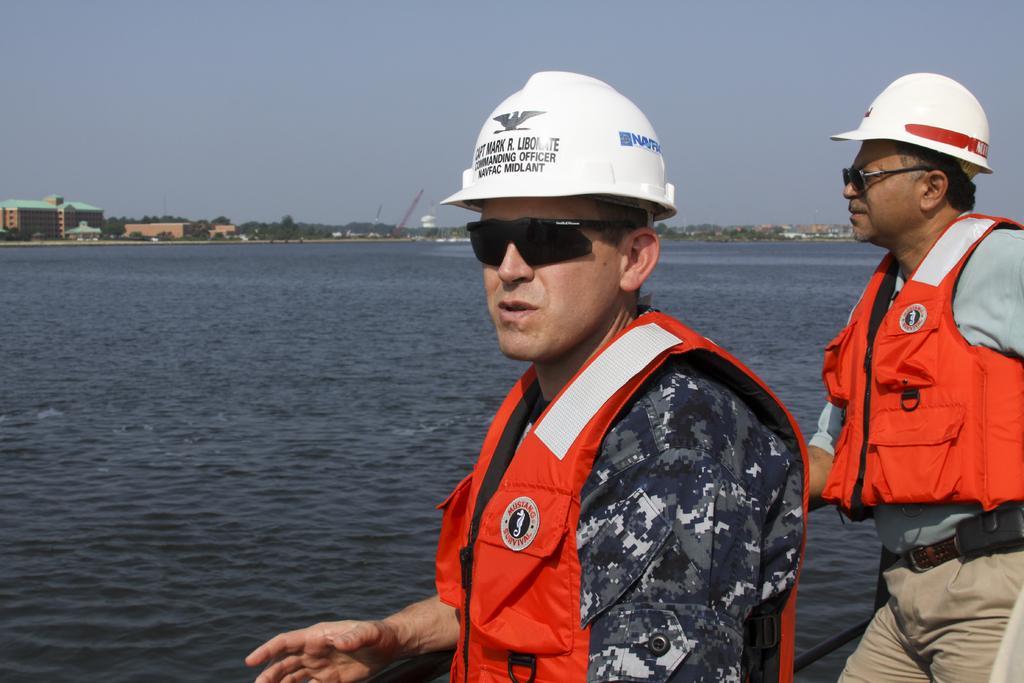Please provide a concise description of this image. In this picture there are two persons with red jackets and white helmets are standing. At the back there are buildings, trees and there are cranes. At the top there is sky. At the bottom there is water. 